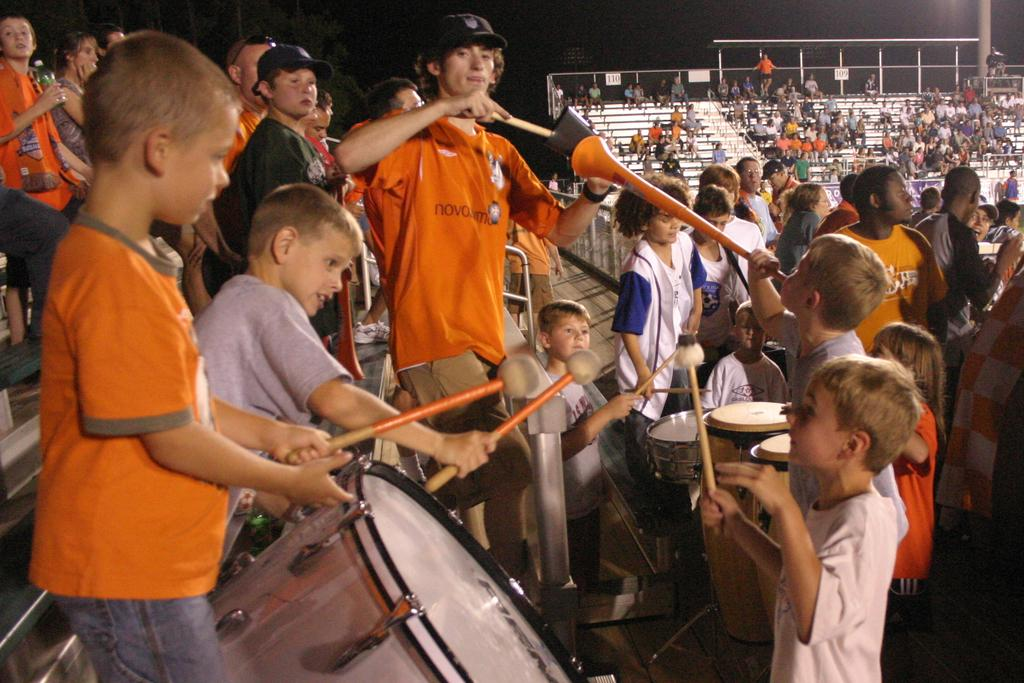What type of location is depicted in the image? The image appears to be inside a stadium. What are the people in the image doing? There is a group of people standing in the image, and some of them are playing musical instruments. Can you tell me how many rats are visible in the image? There are no rats present in the image; it features a group of people standing and playing musical instruments inside a stadium. 